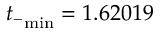Convert formula to latex. <formula><loc_0><loc_0><loc_500><loc_500>{ t _ { - } } _ { \min } = 1 . 6 2 0 1 9</formula> 